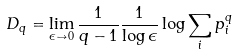Convert formula to latex. <formula><loc_0><loc_0><loc_500><loc_500>D _ { q } = \lim _ { \epsilon \to 0 } \frac { 1 } { q - 1 } \frac { 1 } { \log \epsilon } \log \sum _ { i } p _ { i } ^ { q }</formula> 